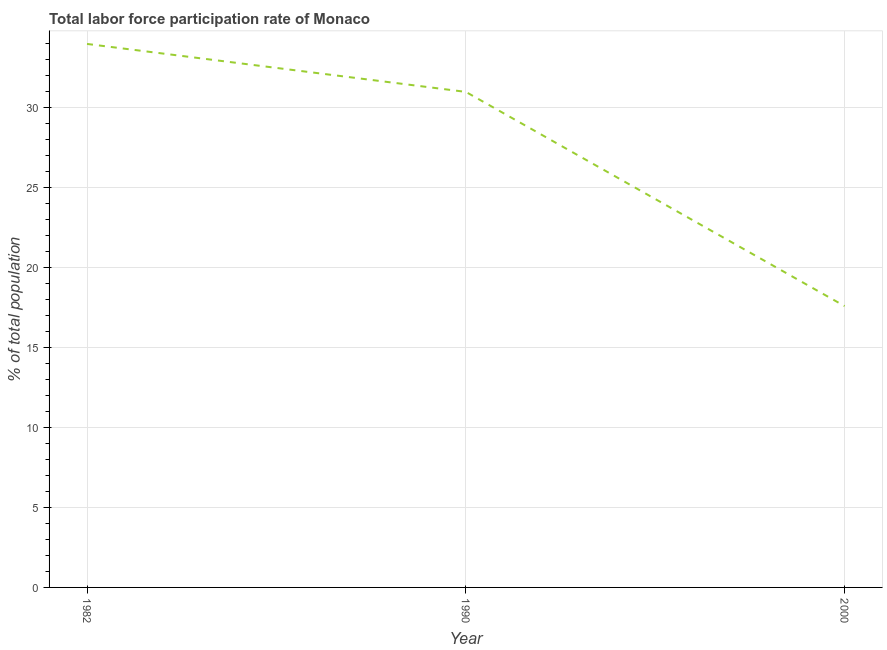Across all years, what is the maximum total labor force participation rate?
Provide a short and direct response. 34. Across all years, what is the minimum total labor force participation rate?
Your answer should be compact. 17.6. What is the sum of the total labor force participation rate?
Ensure brevity in your answer.  82.6. What is the difference between the total labor force participation rate in 1990 and 2000?
Make the answer very short. 13.4. What is the average total labor force participation rate per year?
Your response must be concise. 27.53. What is the median total labor force participation rate?
Give a very brief answer. 31. Do a majority of the years between 1982 and 2000 (inclusive) have total labor force participation rate greater than 9 %?
Ensure brevity in your answer.  Yes. What is the ratio of the total labor force participation rate in 1982 to that in 1990?
Provide a succinct answer. 1.1. What is the difference between the highest and the lowest total labor force participation rate?
Give a very brief answer. 16.4. Are the values on the major ticks of Y-axis written in scientific E-notation?
Provide a succinct answer. No. Does the graph contain any zero values?
Give a very brief answer. No. What is the title of the graph?
Provide a short and direct response. Total labor force participation rate of Monaco. What is the label or title of the Y-axis?
Your answer should be very brief. % of total population. What is the % of total population of 1982?
Offer a terse response. 34. What is the % of total population of 1990?
Make the answer very short. 31. What is the % of total population in 2000?
Your response must be concise. 17.6. What is the difference between the % of total population in 1982 and 1990?
Ensure brevity in your answer.  3. What is the difference between the % of total population in 1990 and 2000?
Offer a very short reply. 13.4. What is the ratio of the % of total population in 1982 to that in 1990?
Provide a short and direct response. 1.1. What is the ratio of the % of total population in 1982 to that in 2000?
Your response must be concise. 1.93. What is the ratio of the % of total population in 1990 to that in 2000?
Make the answer very short. 1.76. 